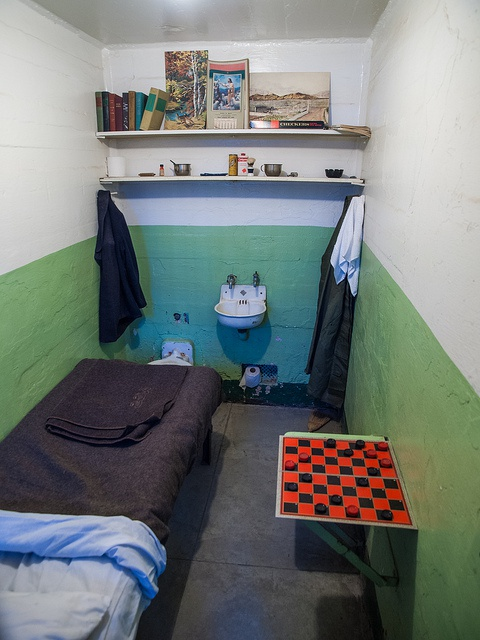Describe the objects in this image and their specific colors. I can see bed in darkgray and black tones, sink in darkgray, gray, and lightgray tones, book in darkgray, tan, gray, and teal tones, toilet in darkgray and gray tones, and book in darkgray, black, lightgray, gray, and maroon tones in this image. 